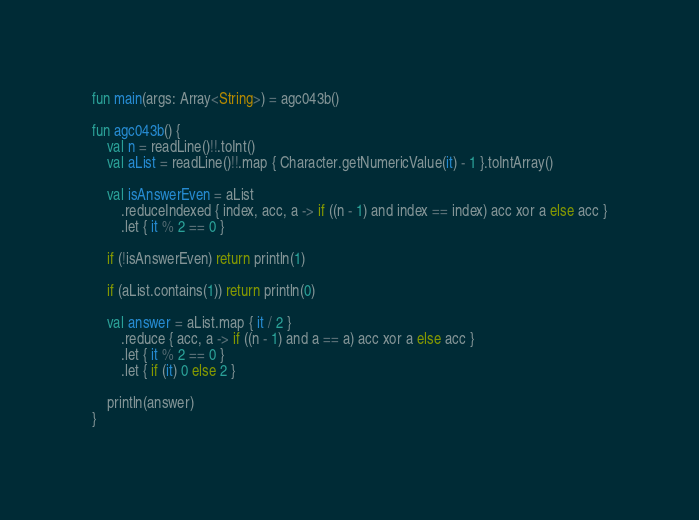Convert code to text. <code><loc_0><loc_0><loc_500><loc_500><_Kotlin_>fun main(args: Array<String>) = agc043b()

fun agc043b() {
    val n = readLine()!!.toInt()
    val aList = readLine()!!.map { Character.getNumericValue(it) - 1 }.toIntArray()

    val isAnswerEven = aList
        .reduceIndexed { index, acc, a -> if ((n - 1) and index == index) acc xor a else acc }
        .let { it % 2 == 0 }

    if (!isAnswerEven) return println(1)

    if (aList.contains(1)) return println(0)

    val answer = aList.map { it / 2 }
        .reduce { acc, a -> if ((n - 1) and a == a) acc xor a else acc }
        .let { it % 2 == 0 }
        .let { if (it) 0 else 2 }

    println(answer)
}
</code> 